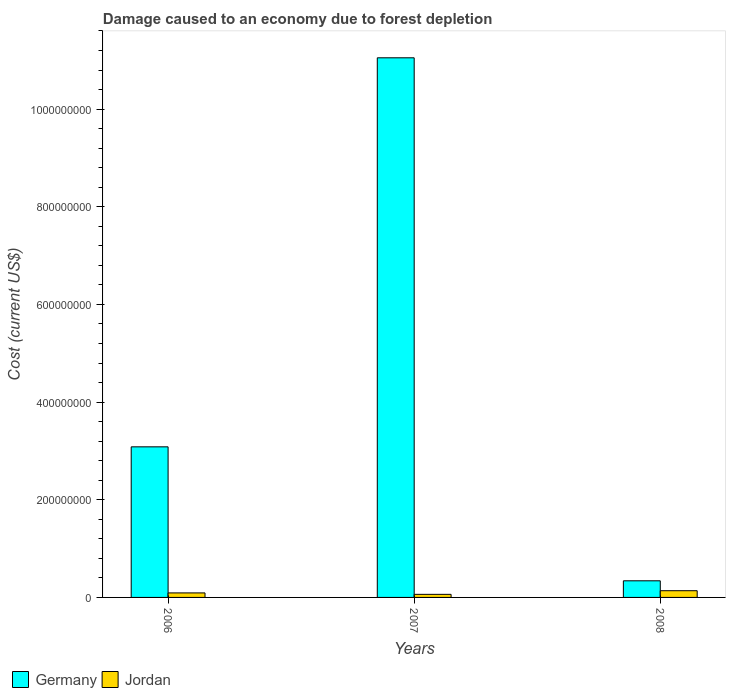How many different coloured bars are there?
Keep it short and to the point. 2. Are the number of bars on each tick of the X-axis equal?
Offer a terse response. Yes. How many bars are there on the 2nd tick from the left?
Keep it short and to the point. 2. What is the label of the 1st group of bars from the left?
Make the answer very short. 2006. In how many cases, is the number of bars for a given year not equal to the number of legend labels?
Provide a short and direct response. 0. What is the cost of damage caused due to forest depletion in Jordan in 2007?
Your response must be concise. 6.30e+06. Across all years, what is the maximum cost of damage caused due to forest depletion in Germany?
Keep it short and to the point. 1.11e+09. Across all years, what is the minimum cost of damage caused due to forest depletion in Germany?
Give a very brief answer. 3.40e+07. In which year was the cost of damage caused due to forest depletion in Germany maximum?
Offer a terse response. 2007. In which year was the cost of damage caused due to forest depletion in Germany minimum?
Offer a very short reply. 2008. What is the total cost of damage caused due to forest depletion in Jordan in the graph?
Make the answer very short. 2.93e+07. What is the difference between the cost of damage caused due to forest depletion in Germany in 2006 and that in 2008?
Your answer should be very brief. 2.74e+08. What is the difference between the cost of damage caused due to forest depletion in Jordan in 2008 and the cost of damage caused due to forest depletion in Germany in 2006?
Your response must be concise. -2.95e+08. What is the average cost of damage caused due to forest depletion in Jordan per year?
Provide a succinct answer. 9.76e+06. In the year 2007, what is the difference between the cost of damage caused due to forest depletion in Germany and cost of damage caused due to forest depletion in Jordan?
Your answer should be very brief. 1.10e+09. In how many years, is the cost of damage caused due to forest depletion in Germany greater than 600000000 US$?
Make the answer very short. 1. What is the ratio of the cost of damage caused due to forest depletion in Germany in 2006 to that in 2007?
Ensure brevity in your answer.  0.28. Is the difference between the cost of damage caused due to forest depletion in Germany in 2006 and 2008 greater than the difference between the cost of damage caused due to forest depletion in Jordan in 2006 and 2008?
Keep it short and to the point. Yes. What is the difference between the highest and the second highest cost of damage caused due to forest depletion in Jordan?
Make the answer very short. 4.52e+06. What is the difference between the highest and the lowest cost of damage caused due to forest depletion in Jordan?
Your answer should be very brief. 7.45e+06. What does the 2nd bar from the right in 2008 represents?
Provide a succinct answer. Germany. Are the values on the major ticks of Y-axis written in scientific E-notation?
Your response must be concise. No. Where does the legend appear in the graph?
Offer a very short reply. Bottom left. How many legend labels are there?
Provide a short and direct response. 2. What is the title of the graph?
Give a very brief answer. Damage caused to an economy due to forest depletion. What is the label or title of the Y-axis?
Give a very brief answer. Cost (current US$). What is the Cost (current US$) of Germany in 2006?
Offer a very short reply. 3.08e+08. What is the Cost (current US$) in Jordan in 2006?
Ensure brevity in your answer.  9.24e+06. What is the Cost (current US$) of Germany in 2007?
Offer a terse response. 1.11e+09. What is the Cost (current US$) in Jordan in 2007?
Keep it short and to the point. 6.30e+06. What is the Cost (current US$) of Germany in 2008?
Make the answer very short. 3.40e+07. What is the Cost (current US$) in Jordan in 2008?
Your answer should be very brief. 1.38e+07. Across all years, what is the maximum Cost (current US$) of Germany?
Ensure brevity in your answer.  1.11e+09. Across all years, what is the maximum Cost (current US$) of Jordan?
Offer a very short reply. 1.38e+07. Across all years, what is the minimum Cost (current US$) of Germany?
Ensure brevity in your answer.  3.40e+07. Across all years, what is the minimum Cost (current US$) of Jordan?
Your answer should be very brief. 6.30e+06. What is the total Cost (current US$) in Germany in the graph?
Ensure brevity in your answer.  1.45e+09. What is the total Cost (current US$) in Jordan in the graph?
Make the answer very short. 2.93e+07. What is the difference between the Cost (current US$) in Germany in 2006 and that in 2007?
Offer a very short reply. -7.97e+08. What is the difference between the Cost (current US$) in Jordan in 2006 and that in 2007?
Your response must be concise. 2.93e+06. What is the difference between the Cost (current US$) in Germany in 2006 and that in 2008?
Offer a very short reply. 2.74e+08. What is the difference between the Cost (current US$) of Jordan in 2006 and that in 2008?
Your answer should be compact. -4.52e+06. What is the difference between the Cost (current US$) of Germany in 2007 and that in 2008?
Give a very brief answer. 1.07e+09. What is the difference between the Cost (current US$) of Jordan in 2007 and that in 2008?
Provide a short and direct response. -7.45e+06. What is the difference between the Cost (current US$) of Germany in 2006 and the Cost (current US$) of Jordan in 2007?
Ensure brevity in your answer.  3.02e+08. What is the difference between the Cost (current US$) of Germany in 2006 and the Cost (current US$) of Jordan in 2008?
Your answer should be very brief. 2.95e+08. What is the difference between the Cost (current US$) in Germany in 2007 and the Cost (current US$) in Jordan in 2008?
Ensure brevity in your answer.  1.09e+09. What is the average Cost (current US$) of Germany per year?
Offer a terse response. 4.83e+08. What is the average Cost (current US$) of Jordan per year?
Your response must be concise. 9.76e+06. In the year 2006, what is the difference between the Cost (current US$) of Germany and Cost (current US$) of Jordan?
Keep it short and to the point. 2.99e+08. In the year 2007, what is the difference between the Cost (current US$) in Germany and Cost (current US$) in Jordan?
Provide a short and direct response. 1.10e+09. In the year 2008, what is the difference between the Cost (current US$) in Germany and Cost (current US$) in Jordan?
Your response must be concise. 2.03e+07. What is the ratio of the Cost (current US$) of Germany in 2006 to that in 2007?
Ensure brevity in your answer.  0.28. What is the ratio of the Cost (current US$) in Jordan in 2006 to that in 2007?
Keep it short and to the point. 1.47. What is the ratio of the Cost (current US$) in Germany in 2006 to that in 2008?
Offer a very short reply. 9.06. What is the ratio of the Cost (current US$) in Jordan in 2006 to that in 2008?
Make the answer very short. 0.67. What is the ratio of the Cost (current US$) of Germany in 2007 to that in 2008?
Your answer should be compact. 32.47. What is the ratio of the Cost (current US$) in Jordan in 2007 to that in 2008?
Your response must be concise. 0.46. What is the difference between the highest and the second highest Cost (current US$) of Germany?
Keep it short and to the point. 7.97e+08. What is the difference between the highest and the second highest Cost (current US$) of Jordan?
Provide a succinct answer. 4.52e+06. What is the difference between the highest and the lowest Cost (current US$) of Germany?
Keep it short and to the point. 1.07e+09. What is the difference between the highest and the lowest Cost (current US$) in Jordan?
Make the answer very short. 7.45e+06. 